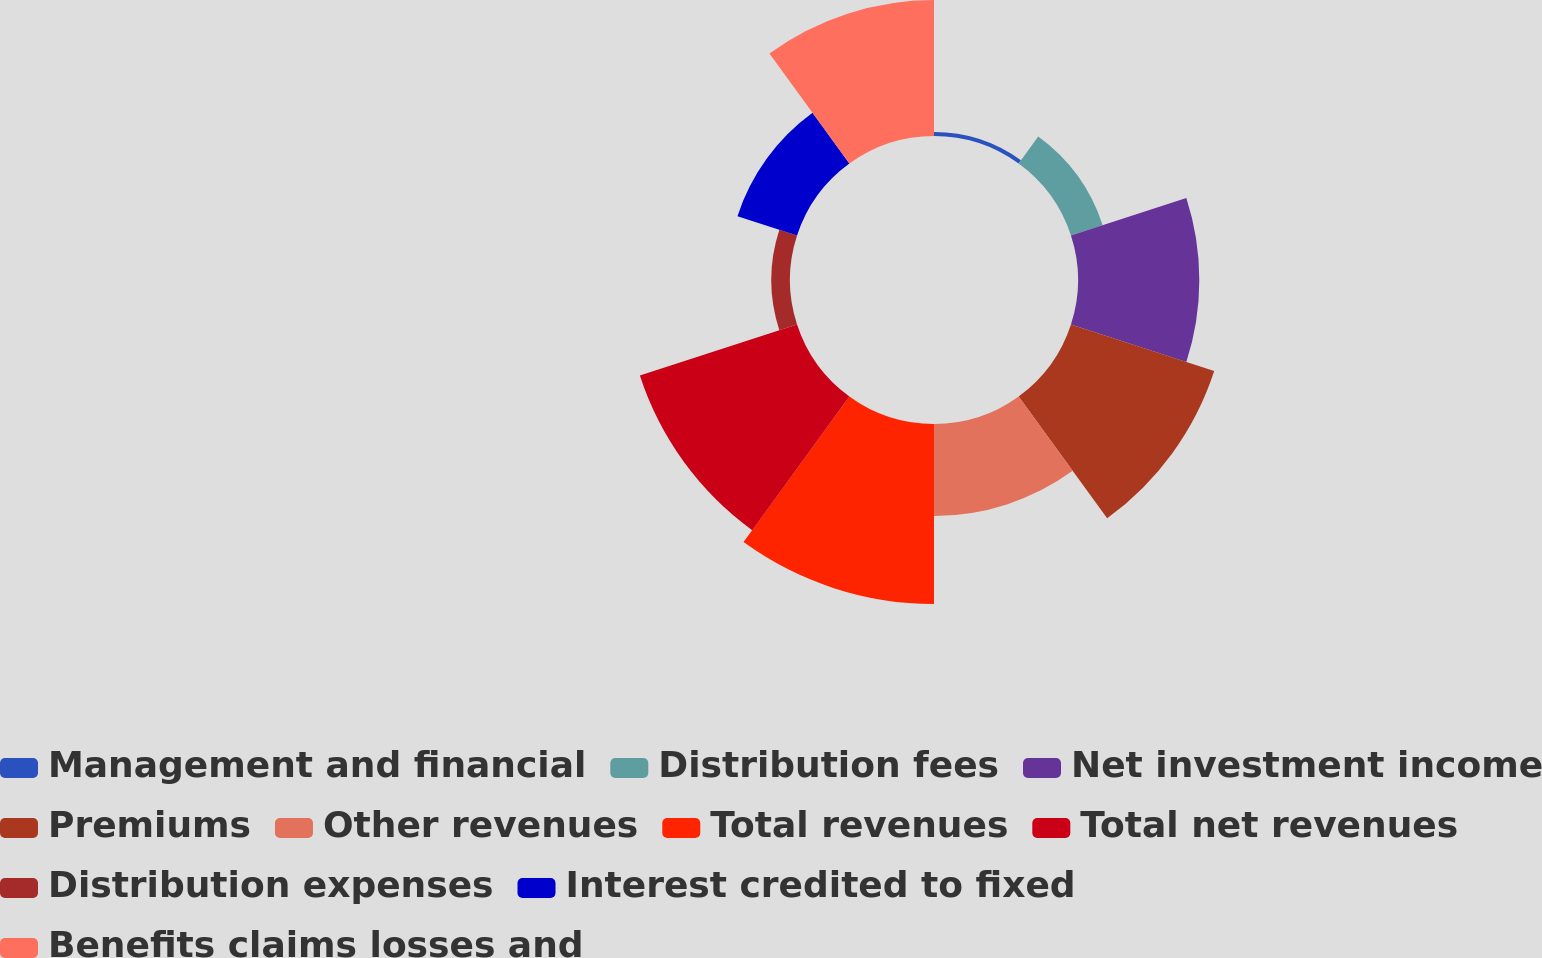<chart> <loc_0><loc_0><loc_500><loc_500><pie_chart><fcel>Management and financial<fcel>Distribution fees<fcel>Net investment income<fcel>Premiums<fcel>Other revenues<fcel>Total revenues<fcel>Total net revenues<fcel>Distribution expenses<fcel>Interest credited to fixed<fcel>Benefits claims losses and<nl><fcel>0.41%<fcel>3.46%<fcel>12.59%<fcel>15.63%<fcel>9.54%<fcel>18.68%<fcel>17.15%<fcel>1.93%<fcel>6.5%<fcel>14.11%<nl></chart> 